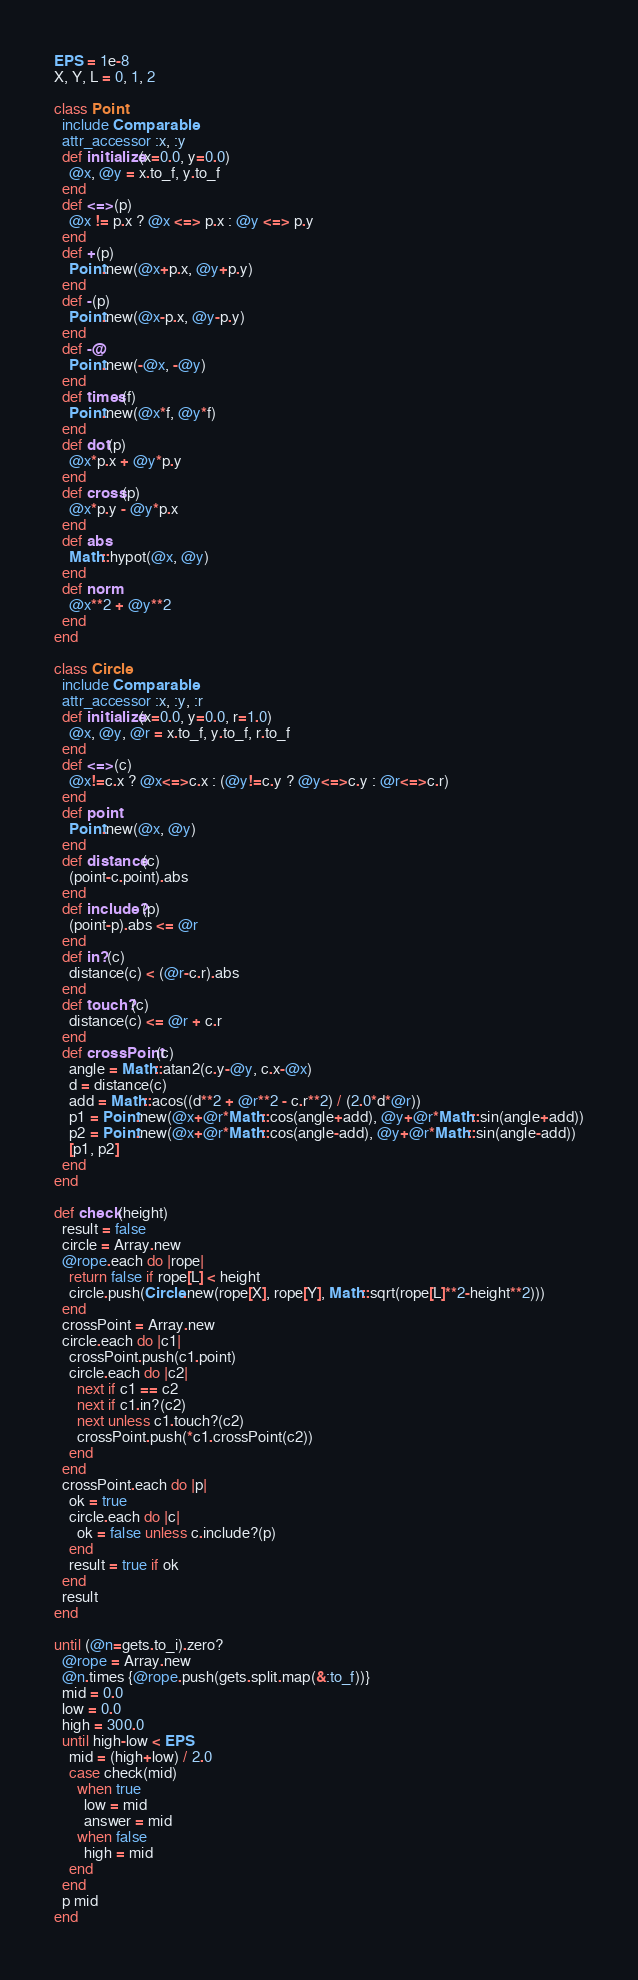Convert code to text. <code><loc_0><loc_0><loc_500><loc_500><_Ruby_>EPS = 1e-8
X, Y, L = 0, 1, 2

class Point
  include Comparable
  attr_accessor :x, :y
  def initialize(x=0.0, y=0.0)
    @x, @y = x.to_f, y.to_f
  end
  def <=>(p)
    @x != p.x ? @x <=> p.x : @y <=> p.y
  end
  def +(p)
    Point.new(@x+p.x, @y+p.y)
  end
  def -(p)
    Point.new(@x-p.x, @y-p.y)
  end
  def -@
    Point.new(-@x, -@y)
  end
  def times(f)
    Point.new(@x*f, @y*f)
  end
  def dot(p)
    @x*p.x + @y*p.y
  end
  def cross(p)
    @x*p.y - @y*p.x
  end
  def abs
    Math::hypot(@x, @y)
  end
  def norm
    @x**2 + @y**2
  end
end

class Circle
  include Comparable
  attr_accessor :x, :y, :r
  def initialize(x=0.0, y=0.0, r=1.0)
    @x, @y, @r = x.to_f, y.to_f, r.to_f
  end
  def <=>(c)
    @x!=c.x ? @x<=>c.x : (@y!=c.y ? @y<=>c.y : @r<=>c.r)
  end
  def point
    Point.new(@x, @y)
  end
  def distance(c)
    (point-c.point).abs
  end
  def include?(p)
    (point-p).abs <= @r
  end
  def in?(c)
    distance(c) < (@r-c.r).abs
  end
  def touch?(c)
    distance(c) <= @r + c.r
  end
  def crossPoint(c)
    angle = Math::atan2(c.y-@y, c.x-@x)
    d = distance(c)
    add = Math::acos((d**2 + @r**2 - c.r**2) / (2.0*d*@r))
    p1 = Point.new(@x+@r*Math::cos(angle+add), @y+@r*Math::sin(angle+add))
    p2 = Point.new(@x+@r*Math::cos(angle-add), @y+@r*Math::sin(angle-add))
    [p1, p2]
  end
end

def check(height)
  result = false
  circle = Array.new
  @rope.each do |rope|
    return false if rope[L] < height
    circle.push(Circle.new(rope[X], rope[Y], Math::sqrt(rope[L]**2-height**2)))
  end
  crossPoint = Array.new
  circle.each do |c1|
    crossPoint.push(c1.point)
    circle.each do |c2|
      next if c1 == c2
      next if c1.in?(c2)
      next unless c1.touch?(c2)
      crossPoint.push(*c1.crossPoint(c2))
    end
  end
  crossPoint.each do |p|
    ok = true
    circle.each do |c|
      ok = false unless c.include?(p)
    end
    result = true if ok
  end
  result
end

until (@n=gets.to_i).zero?
  @rope = Array.new
  @n.times {@rope.push(gets.split.map(&:to_f))}
  mid = 0.0
  low = 0.0
  high = 300.0
  until high-low < EPS
    mid = (high+low) / 2.0
    case check(mid)
      when true
        low = mid
        answer = mid
      when false
        high = mid
    end
  end
  p mid
end</code> 